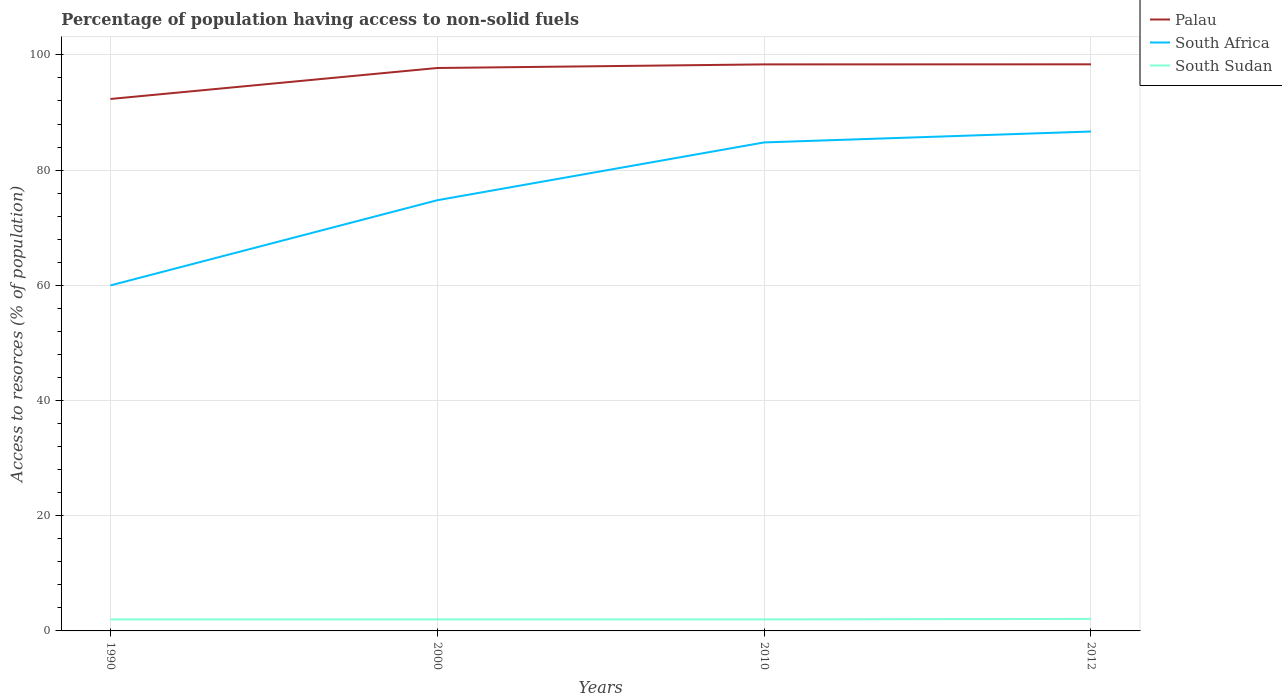How many different coloured lines are there?
Make the answer very short. 3. Is the number of lines equal to the number of legend labels?
Give a very brief answer. Yes. Across all years, what is the maximum percentage of population having access to non-solid fuels in Palau?
Make the answer very short. 92.34. In which year was the percentage of population having access to non-solid fuels in Palau maximum?
Keep it short and to the point. 1990. What is the total percentage of population having access to non-solid fuels in South Sudan in the graph?
Your answer should be very brief. -0.08. What is the difference between the highest and the second highest percentage of population having access to non-solid fuels in South Africa?
Your response must be concise. 26.72. What is the difference between the highest and the lowest percentage of population having access to non-solid fuels in South Sudan?
Ensure brevity in your answer.  1. How many years are there in the graph?
Make the answer very short. 4. What is the difference between two consecutive major ticks on the Y-axis?
Provide a short and direct response. 20. How are the legend labels stacked?
Your answer should be compact. Vertical. What is the title of the graph?
Your answer should be very brief. Percentage of population having access to non-solid fuels. Does "Namibia" appear as one of the legend labels in the graph?
Ensure brevity in your answer.  No. What is the label or title of the Y-axis?
Provide a short and direct response. Access to resorces (% of population). What is the Access to resorces (% of population) in Palau in 1990?
Your response must be concise. 92.34. What is the Access to resorces (% of population) in South Africa in 1990?
Offer a very short reply. 59.98. What is the Access to resorces (% of population) of South Sudan in 1990?
Your answer should be very brief. 2. What is the Access to resorces (% of population) of Palau in 2000?
Offer a very short reply. 97.72. What is the Access to resorces (% of population) in South Africa in 2000?
Your response must be concise. 74.77. What is the Access to resorces (% of population) in South Sudan in 2000?
Provide a short and direct response. 2. What is the Access to resorces (% of population) of Palau in 2010?
Ensure brevity in your answer.  98.35. What is the Access to resorces (% of population) in South Africa in 2010?
Your answer should be very brief. 84.8. What is the Access to resorces (% of population) in South Sudan in 2010?
Your answer should be very brief. 2. What is the Access to resorces (% of population) in Palau in 2012?
Make the answer very short. 98.36. What is the Access to resorces (% of population) of South Africa in 2012?
Give a very brief answer. 86.7. What is the Access to resorces (% of population) of South Sudan in 2012?
Provide a succinct answer. 2.08. Across all years, what is the maximum Access to resorces (% of population) of Palau?
Your response must be concise. 98.36. Across all years, what is the maximum Access to resorces (% of population) of South Africa?
Keep it short and to the point. 86.7. Across all years, what is the maximum Access to resorces (% of population) of South Sudan?
Offer a terse response. 2.08. Across all years, what is the minimum Access to resorces (% of population) of Palau?
Provide a succinct answer. 92.34. Across all years, what is the minimum Access to resorces (% of population) in South Africa?
Provide a short and direct response. 59.98. Across all years, what is the minimum Access to resorces (% of population) in South Sudan?
Offer a terse response. 2. What is the total Access to resorces (% of population) in Palau in the graph?
Make the answer very short. 386.78. What is the total Access to resorces (% of population) of South Africa in the graph?
Offer a very short reply. 306.24. What is the total Access to resorces (% of population) of South Sudan in the graph?
Provide a succinct answer. 8.09. What is the difference between the Access to resorces (% of population) in Palau in 1990 and that in 2000?
Your answer should be very brief. -5.38. What is the difference between the Access to resorces (% of population) in South Africa in 1990 and that in 2000?
Give a very brief answer. -14.79. What is the difference between the Access to resorces (% of population) in Palau in 1990 and that in 2010?
Ensure brevity in your answer.  -6.01. What is the difference between the Access to resorces (% of population) of South Africa in 1990 and that in 2010?
Keep it short and to the point. -24.82. What is the difference between the Access to resorces (% of population) of South Sudan in 1990 and that in 2010?
Provide a short and direct response. -0. What is the difference between the Access to resorces (% of population) in Palau in 1990 and that in 2012?
Keep it short and to the point. -6.02. What is the difference between the Access to resorces (% of population) in South Africa in 1990 and that in 2012?
Provide a succinct answer. -26.72. What is the difference between the Access to resorces (% of population) in South Sudan in 1990 and that in 2012?
Make the answer very short. -0.08. What is the difference between the Access to resorces (% of population) of Palau in 2000 and that in 2010?
Keep it short and to the point. -0.63. What is the difference between the Access to resorces (% of population) of South Africa in 2000 and that in 2010?
Your answer should be compact. -10.04. What is the difference between the Access to resorces (% of population) of South Sudan in 2000 and that in 2010?
Your answer should be compact. -0. What is the difference between the Access to resorces (% of population) in Palau in 2000 and that in 2012?
Your answer should be very brief. -0.64. What is the difference between the Access to resorces (% of population) of South Africa in 2000 and that in 2012?
Keep it short and to the point. -11.93. What is the difference between the Access to resorces (% of population) in South Sudan in 2000 and that in 2012?
Your response must be concise. -0.08. What is the difference between the Access to resorces (% of population) in Palau in 2010 and that in 2012?
Ensure brevity in your answer.  -0.01. What is the difference between the Access to resorces (% of population) in South Africa in 2010 and that in 2012?
Provide a succinct answer. -1.89. What is the difference between the Access to resorces (% of population) in South Sudan in 2010 and that in 2012?
Ensure brevity in your answer.  -0.08. What is the difference between the Access to resorces (% of population) in Palau in 1990 and the Access to resorces (% of population) in South Africa in 2000?
Make the answer very short. 17.58. What is the difference between the Access to resorces (% of population) of Palau in 1990 and the Access to resorces (% of population) of South Sudan in 2000?
Your answer should be compact. 90.34. What is the difference between the Access to resorces (% of population) in South Africa in 1990 and the Access to resorces (% of population) in South Sudan in 2000?
Provide a short and direct response. 57.98. What is the difference between the Access to resorces (% of population) in Palau in 1990 and the Access to resorces (% of population) in South Africa in 2010?
Your answer should be very brief. 7.54. What is the difference between the Access to resorces (% of population) of Palau in 1990 and the Access to resorces (% of population) of South Sudan in 2010?
Your response must be concise. 90.34. What is the difference between the Access to resorces (% of population) in South Africa in 1990 and the Access to resorces (% of population) in South Sudan in 2010?
Make the answer very short. 57.97. What is the difference between the Access to resorces (% of population) of Palau in 1990 and the Access to resorces (% of population) of South Africa in 2012?
Your response must be concise. 5.65. What is the difference between the Access to resorces (% of population) of Palau in 1990 and the Access to resorces (% of population) of South Sudan in 2012?
Provide a succinct answer. 90.26. What is the difference between the Access to resorces (% of population) of South Africa in 1990 and the Access to resorces (% of population) of South Sudan in 2012?
Offer a very short reply. 57.89. What is the difference between the Access to resorces (% of population) of Palau in 2000 and the Access to resorces (% of population) of South Africa in 2010?
Offer a very short reply. 12.92. What is the difference between the Access to resorces (% of population) of Palau in 2000 and the Access to resorces (% of population) of South Sudan in 2010?
Give a very brief answer. 95.72. What is the difference between the Access to resorces (% of population) in South Africa in 2000 and the Access to resorces (% of population) in South Sudan in 2010?
Give a very brief answer. 72.76. What is the difference between the Access to resorces (% of population) of Palau in 2000 and the Access to resorces (% of population) of South Africa in 2012?
Keep it short and to the point. 11.03. What is the difference between the Access to resorces (% of population) of Palau in 2000 and the Access to resorces (% of population) of South Sudan in 2012?
Give a very brief answer. 95.64. What is the difference between the Access to resorces (% of population) of South Africa in 2000 and the Access to resorces (% of population) of South Sudan in 2012?
Keep it short and to the point. 72.68. What is the difference between the Access to resorces (% of population) in Palau in 2010 and the Access to resorces (% of population) in South Africa in 2012?
Keep it short and to the point. 11.65. What is the difference between the Access to resorces (% of population) of Palau in 2010 and the Access to resorces (% of population) of South Sudan in 2012?
Your answer should be very brief. 96.27. What is the difference between the Access to resorces (% of population) of South Africa in 2010 and the Access to resorces (% of population) of South Sudan in 2012?
Give a very brief answer. 82.72. What is the average Access to resorces (% of population) of Palau per year?
Offer a very short reply. 96.69. What is the average Access to resorces (% of population) of South Africa per year?
Make the answer very short. 76.56. What is the average Access to resorces (% of population) of South Sudan per year?
Keep it short and to the point. 2.02. In the year 1990, what is the difference between the Access to resorces (% of population) of Palau and Access to resorces (% of population) of South Africa?
Provide a short and direct response. 32.37. In the year 1990, what is the difference between the Access to resorces (% of population) of Palau and Access to resorces (% of population) of South Sudan?
Ensure brevity in your answer.  90.34. In the year 1990, what is the difference between the Access to resorces (% of population) in South Africa and Access to resorces (% of population) in South Sudan?
Offer a very short reply. 57.98. In the year 2000, what is the difference between the Access to resorces (% of population) of Palau and Access to resorces (% of population) of South Africa?
Ensure brevity in your answer.  22.96. In the year 2000, what is the difference between the Access to resorces (% of population) in Palau and Access to resorces (% of population) in South Sudan?
Give a very brief answer. 95.72. In the year 2000, what is the difference between the Access to resorces (% of population) in South Africa and Access to resorces (% of population) in South Sudan?
Offer a very short reply. 72.77. In the year 2010, what is the difference between the Access to resorces (% of population) of Palau and Access to resorces (% of population) of South Africa?
Offer a very short reply. 13.55. In the year 2010, what is the difference between the Access to resorces (% of population) of Palau and Access to resorces (% of population) of South Sudan?
Your answer should be compact. 96.35. In the year 2010, what is the difference between the Access to resorces (% of population) in South Africa and Access to resorces (% of population) in South Sudan?
Your answer should be very brief. 82.8. In the year 2012, what is the difference between the Access to resorces (% of population) in Palau and Access to resorces (% of population) in South Africa?
Offer a very short reply. 11.66. In the year 2012, what is the difference between the Access to resorces (% of population) of Palau and Access to resorces (% of population) of South Sudan?
Your answer should be very brief. 96.28. In the year 2012, what is the difference between the Access to resorces (% of population) in South Africa and Access to resorces (% of population) in South Sudan?
Offer a very short reply. 84.61. What is the ratio of the Access to resorces (% of population) in Palau in 1990 to that in 2000?
Your answer should be very brief. 0.94. What is the ratio of the Access to resorces (% of population) in South Africa in 1990 to that in 2000?
Provide a short and direct response. 0.8. What is the ratio of the Access to resorces (% of population) in Palau in 1990 to that in 2010?
Your response must be concise. 0.94. What is the ratio of the Access to resorces (% of population) of South Africa in 1990 to that in 2010?
Offer a very short reply. 0.71. What is the ratio of the Access to resorces (% of population) of Palau in 1990 to that in 2012?
Your answer should be very brief. 0.94. What is the ratio of the Access to resorces (% of population) of South Africa in 1990 to that in 2012?
Make the answer very short. 0.69. What is the ratio of the Access to resorces (% of population) of South Sudan in 1990 to that in 2012?
Offer a very short reply. 0.96. What is the ratio of the Access to resorces (% of population) of Palau in 2000 to that in 2010?
Ensure brevity in your answer.  0.99. What is the ratio of the Access to resorces (% of population) of South Africa in 2000 to that in 2010?
Offer a very short reply. 0.88. What is the ratio of the Access to resorces (% of population) of South Sudan in 2000 to that in 2010?
Keep it short and to the point. 1. What is the ratio of the Access to resorces (% of population) in Palau in 2000 to that in 2012?
Keep it short and to the point. 0.99. What is the ratio of the Access to resorces (% of population) in South Africa in 2000 to that in 2012?
Make the answer very short. 0.86. What is the ratio of the Access to resorces (% of population) of South Sudan in 2000 to that in 2012?
Give a very brief answer. 0.96. What is the ratio of the Access to resorces (% of population) of South Africa in 2010 to that in 2012?
Offer a very short reply. 0.98. What is the ratio of the Access to resorces (% of population) in South Sudan in 2010 to that in 2012?
Make the answer very short. 0.96. What is the difference between the highest and the second highest Access to resorces (% of population) in Palau?
Your answer should be compact. 0.01. What is the difference between the highest and the second highest Access to resorces (% of population) of South Africa?
Offer a terse response. 1.89. What is the difference between the highest and the second highest Access to resorces (% of population) in South Sudan?
Offer a terse response. 0.08. What is the difference between the highest and the lowest Access to resorces (% of population) in Palau?
Ensure brevity in your answer.  6.02. What is the difference between the highest and the lowest Access to resorces (% of population) of South Africa?
Your answer should be compact. 26.72. What is the difference between the highest and the lowest Access to resorces (% of population) of South Sudan?
Ensure brevity in your answer.  0.08. 